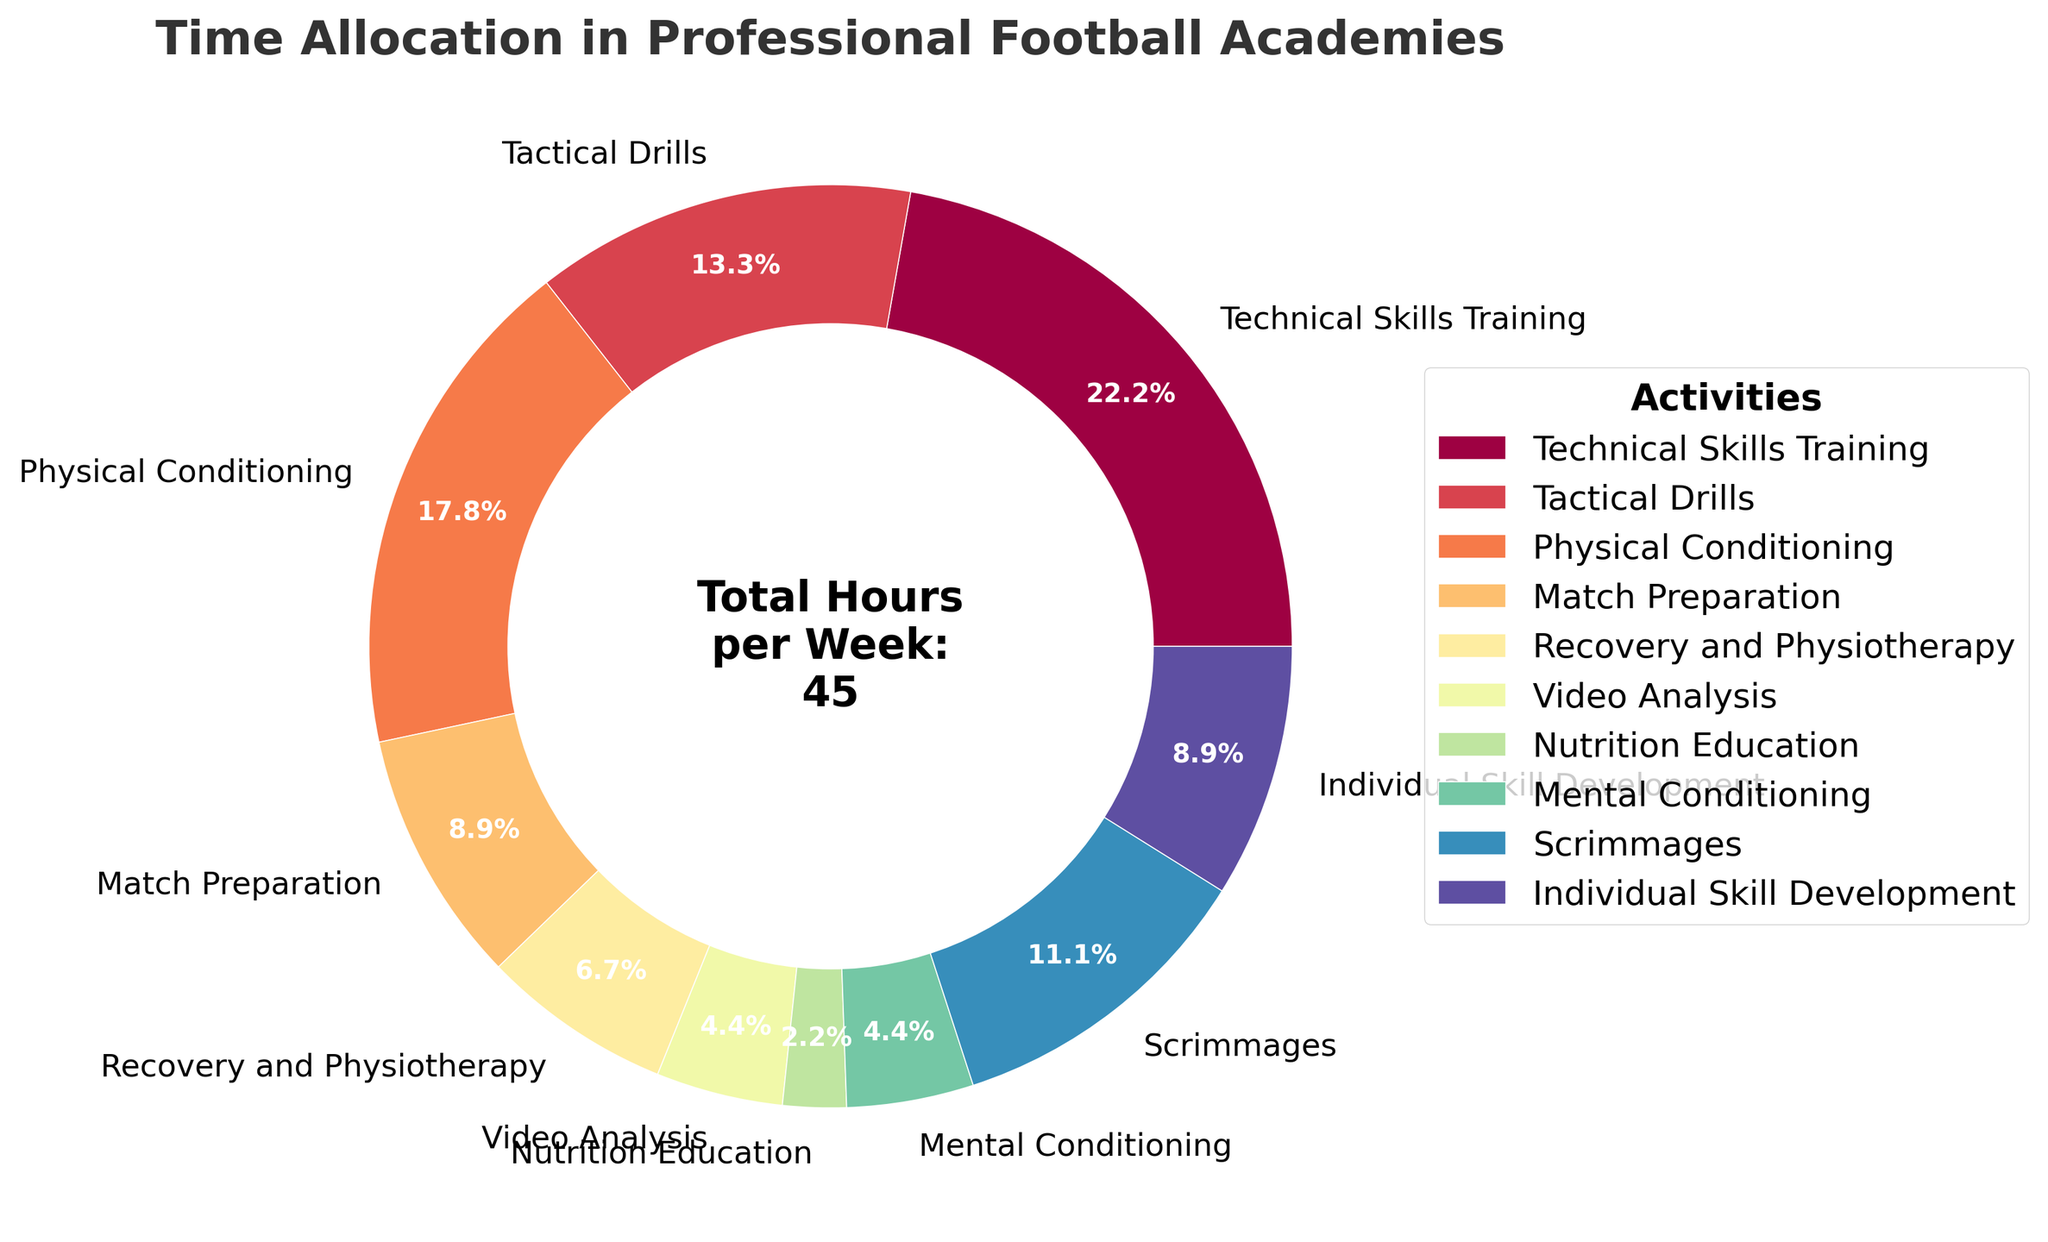Which training activity has the highest allocation of hours per week? The section with the highest percentage on the pie chart represents the activity with the most hours allocated. From the chart, "Technical Skills Training" has the largest section.
Answer: Technical Skills Training How many hours per week are spent on activities related to mental preparation? Mental preparation involves "Mental Conditioning" and "Video Analysis". By summing their respective hours (2 + 2), we get the total.
Answer: 4 Which two activities have the least time allocation, and how many hours are spent on each? The two smallest sections on the pie chart represent the activities with the least hours. These are "Video Analysis" and "Nutrition Education", each with their own hours labeled.
Answer: Video Analysis (2 hours) and Nutrition Education (1 hour) What is the percentage difference in time allocation between "Scrimmages" and "Match Preparation"? Calculate the hours for each (Scrimmages: 5 hours, Match Preparation: 4 hours), find the difference (5 - 4 = 1 hour), and compute the percentage difference relative to 45 total hours (1/45 * 100 ≈ 2.22%).
Answer: 2.22% How many more hours are spent on "Physical Conditioning" compared to "Match Preparation"? Look at the sections for "Physical Conditioning" (8 hours) and "Match Preparation" (4 hours). Subtract hours for Match Preparation from Physical Conditioning (8 - 4).
Answer: 4 If an aspiring player had to cut their training by 10%, how many total hours would this amount to, and how would this be distributed among "Technical Skills Training" and "Tactical Drills"? Calculate 10% of the total training hours (45 * 0.10 = 4.5 hours). For redistribution, apply 10% reduction to each activity: Technical Skills Training (10 * 0.90 = 9 hours), Tactical Drills (6 * 0.90 = 5.4 hours).
Answer: 4.5 hours total, with Technical Skills Training (9 hours) and Tactical Drills (5.4 hours) What is the combined percentage of total weekly hours spent on recovery and physiotherapy, and nutrition education? Sum the hours (Recovery and Physiotherapy: 3 hours, Nutrition Education: 1 hour), then calculate the percentage (4/45 * 100 ≈ 8.89%).
Answer: 8.89% Which activity has more hours allocated, "Scrimmages" or "Individual Skill Development"? Compare the sections for "Scrimmages" (5 hours) and "Individual Skill Development" (4 hours). The one with the larger section has more hours.
Answer: Scrimmages If the academy decided to double the hours for "Video Analysis", what percentage of the total week would now be dedicated to it? Double the "Video Analysis" hours from 2 to 4. Then calculate the new percentage (4/47 * 100 ≈ 8.51%) considering the new total hours (45+2=47).
Answer: 8.51% 